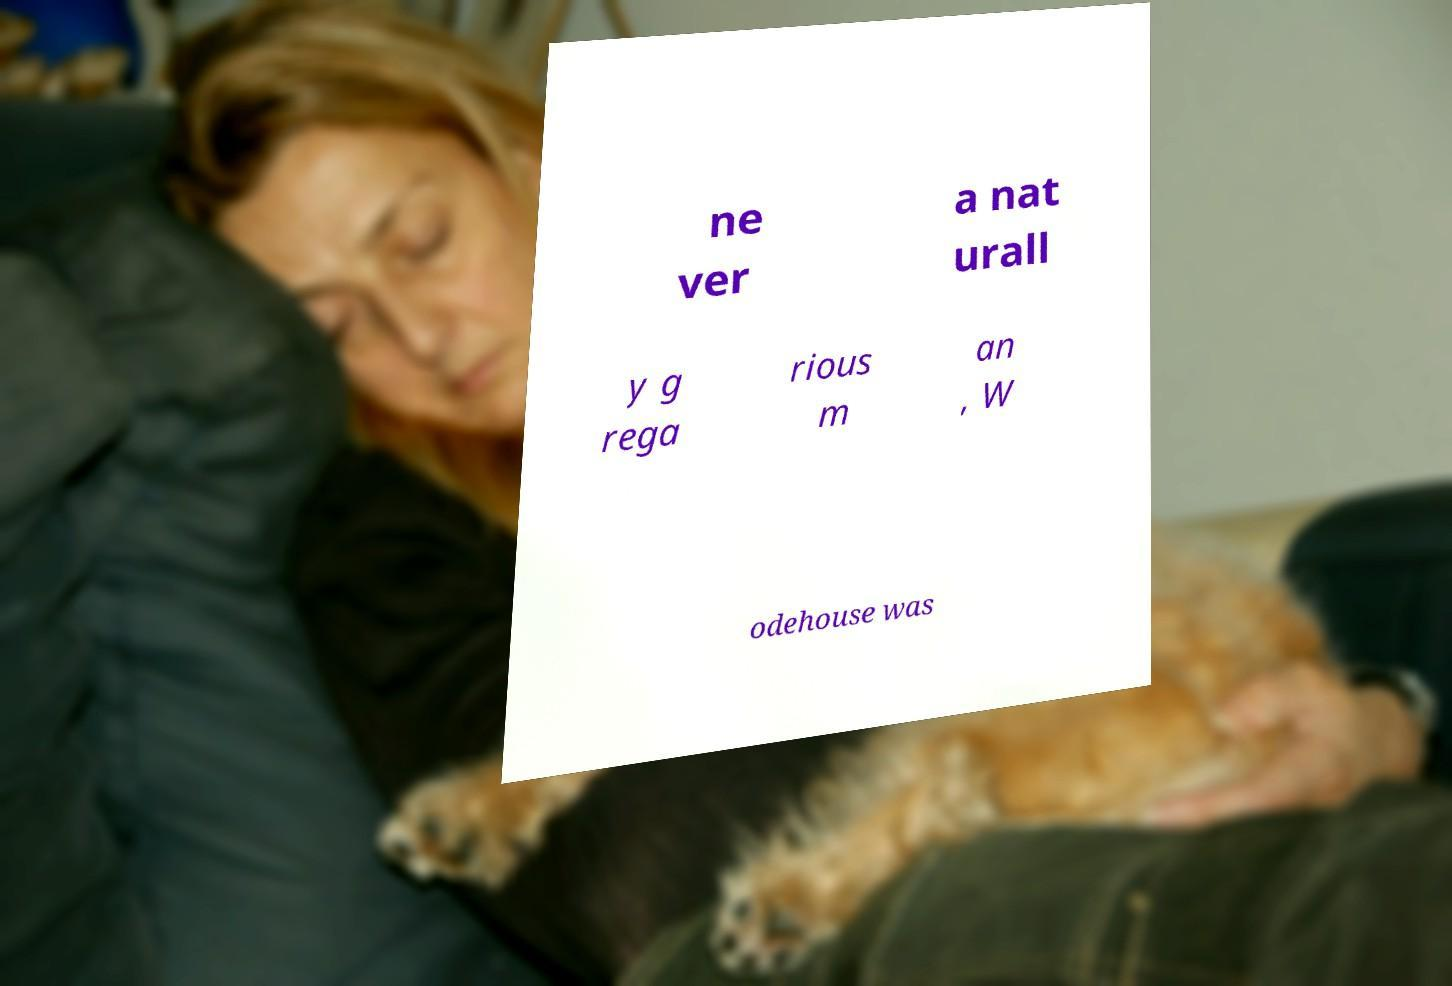What messages or text are displayed in this image? I need them in a readable, typed format. ne ver a nat urall y g rega rious m an , W odehouse was 